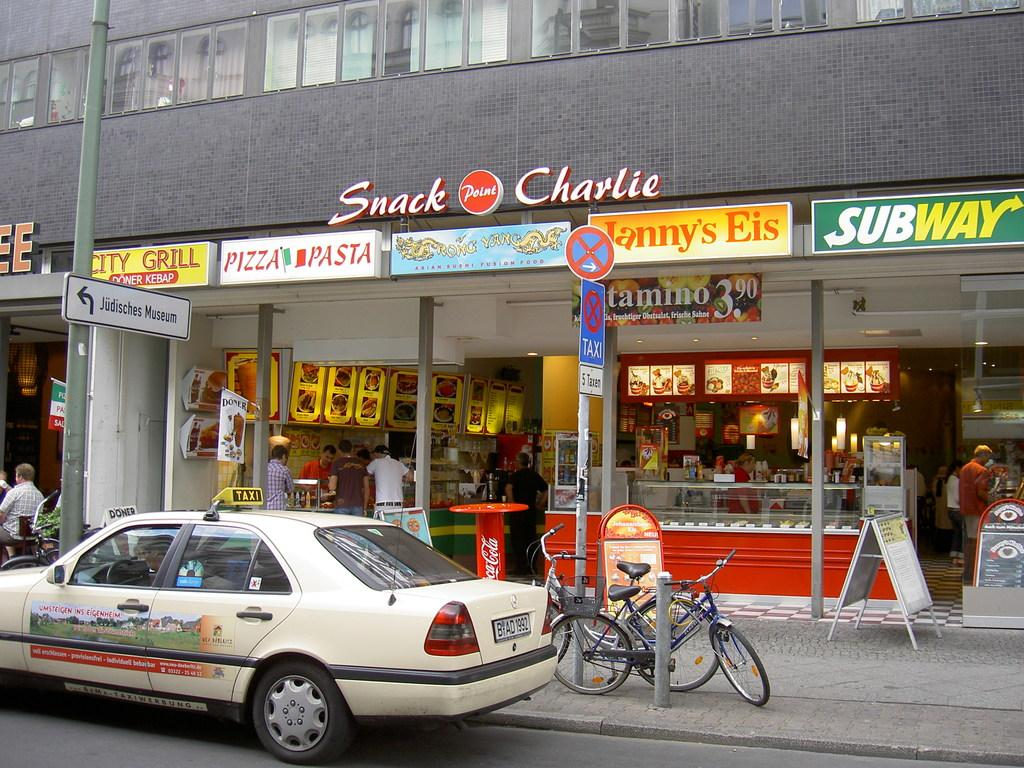<image>
Render a clear and concise summary of the photo. a snack charlie sign that is above the street 